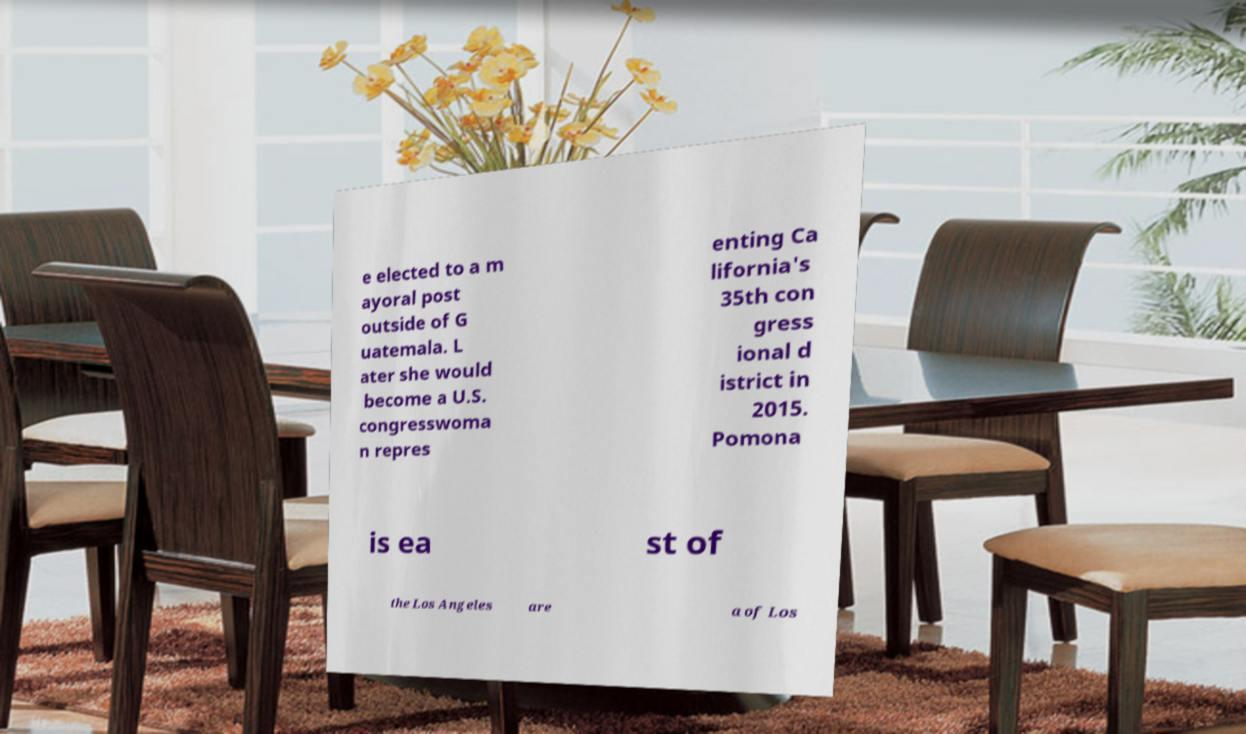Could you extract and type out the text from this image? e elected to a m ayoral post outside of G uatemala. L ater she would become a U.S. congresswoma n repres enting Ca lifornia's 35th con gress ional d istrict in 2015. Pomona is ea st of the Los Angeles are a of Los 